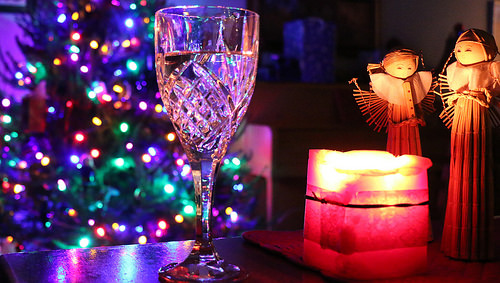<image>
Can you confirm if the glass cup is behind the tree lights? Yes. From this viewpoint, the glass cup is positioned behind the tree lights, with the tree lights partially or fully occluding the glass cup. 